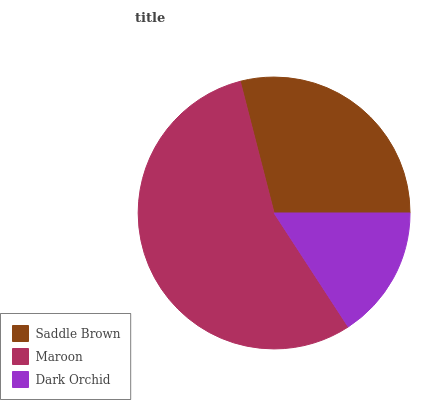Is Dark Orchid the minimum?
Answer yes or no. Yes. Is Maroon the maximum?
Answer yes or no. Yes. Is Maroon the minimum?
Answer yes or no. No. Is Dark Orchid the maximum?
Answer yes or no. No. Is Maroon greater than Dark Orchid?
Answer yes or no. Yes. Is Dark Orchid less than Maroon?
Answer yes or no. Yes. Is Dark Orchid greater than Maroon?
Answer yes or no. No. Is Maroon less than Dark Orchid?
Answer yes or no. No. Is Saddle Brown the high median?
Answer yes or no. Yes. Is Saddle Brown the low median?
Answer yes or no. Yes. Is Maroon the high median?
Answer yes or no. No. Is Dark Orchid the low median?
Answer yes or no. No. 